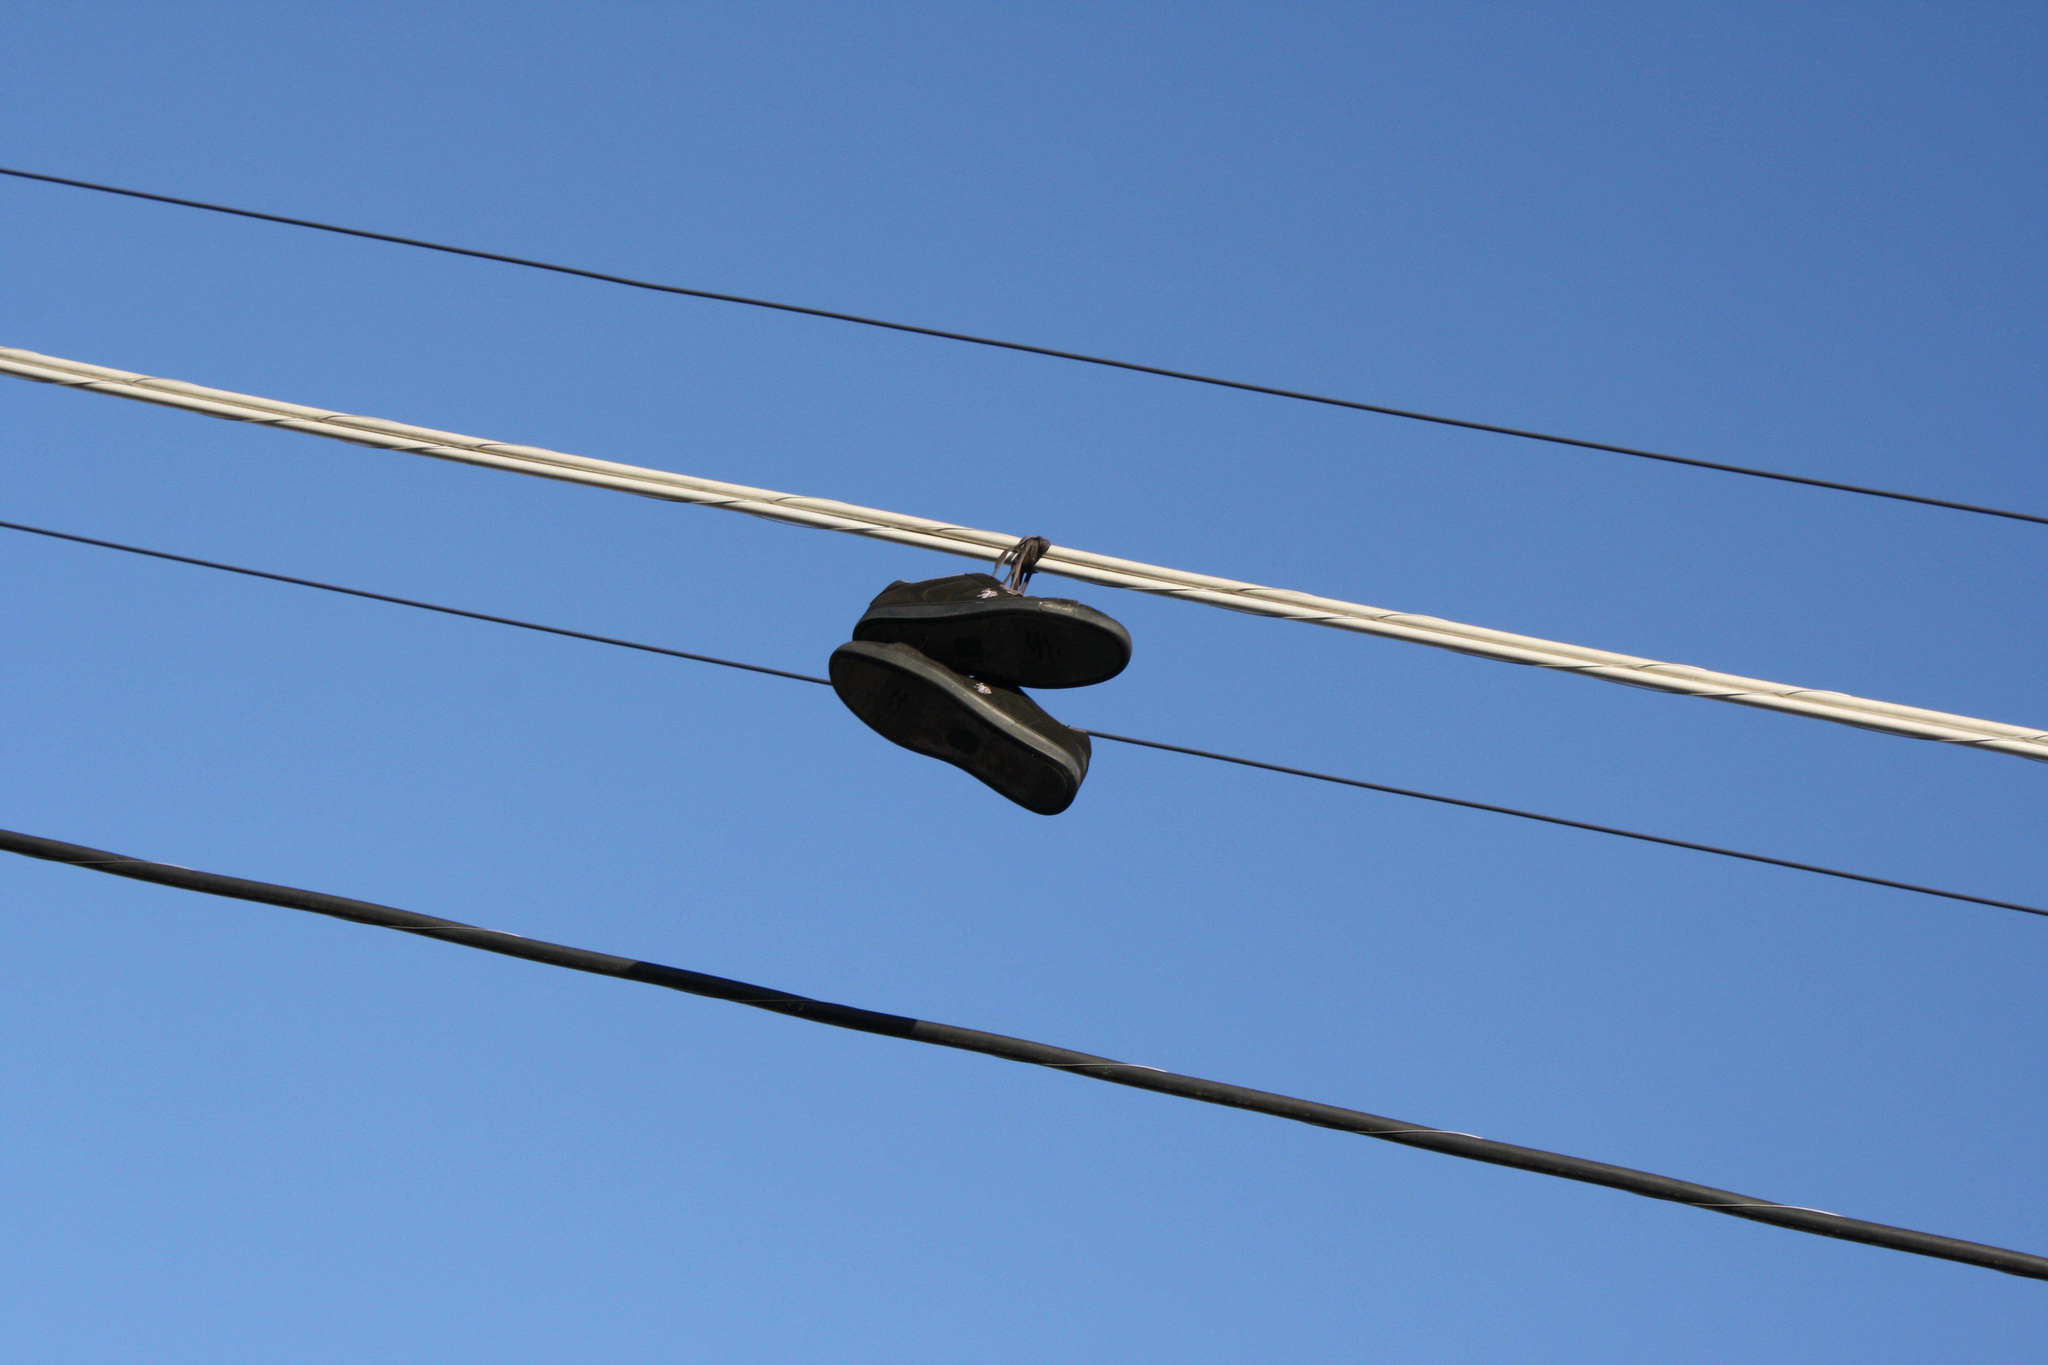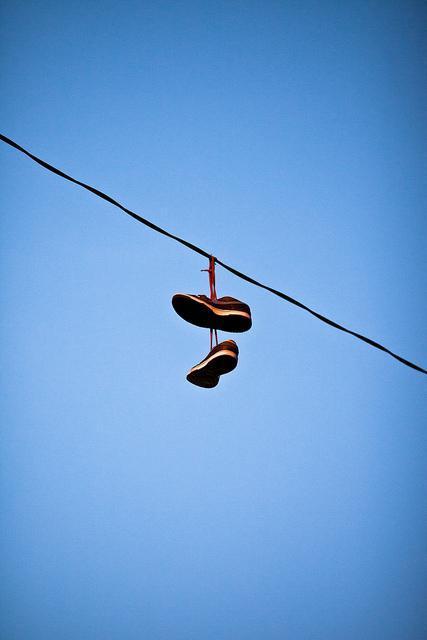The first image is the image on the left, the second image is the image on the right. For the images displayed, is the sentence "There are no more than 2 pairs of shoes hanging from a power line." factually correct? Answer yes or no. Yes. The first image is the image on the left, the second image is the image on the right. For the images displayed, is the sentence "There are exactly two shoes hanging on the line in the image on the right" factually correct? Answer yes or no. Yes. The first image is the image on the left, the second image is the image on the right. Assess this claim about the two images: "Multiple pairs of shoes are hanging from the power lines in at least one picture.". Correct or not? Answer yes or no. No. The first image is the image on the left, the second image is the image on the right. For the images displayed, is the sentence "Left image shows just one pair of sneakers dangling from a wire." factually correct? Answer yes or no. Yes. 